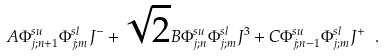Convert formula to latex. <formula><loc_0><loc_0><loc_500><loc_500>A \Phi ^ { s u } _ { j ; n + 1 } \Phi ^ { s l } _ { j ; m } J ^ { - } + \sqrt { 2 } B \Phi ^ { s u } _ { j ; n } \Phi ^ { s l } _ { j ; m } J ^ { 3 } + C \Phi ^ { s u } _ { j ; n - 1 } \Phi ^ { s l } _ { j ; m } J ^ { + } \ .</formula> 